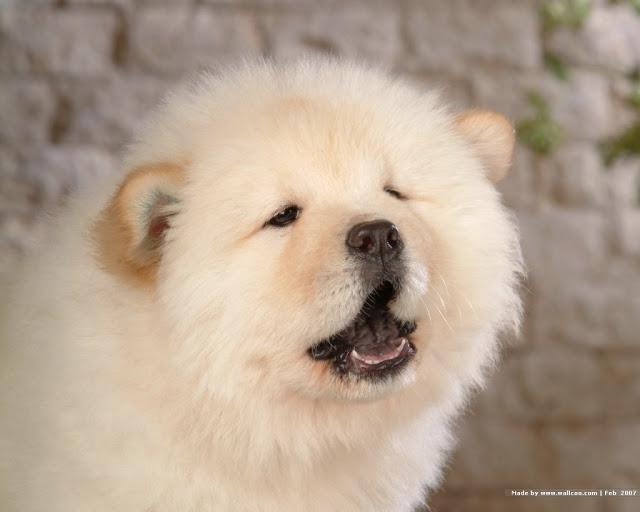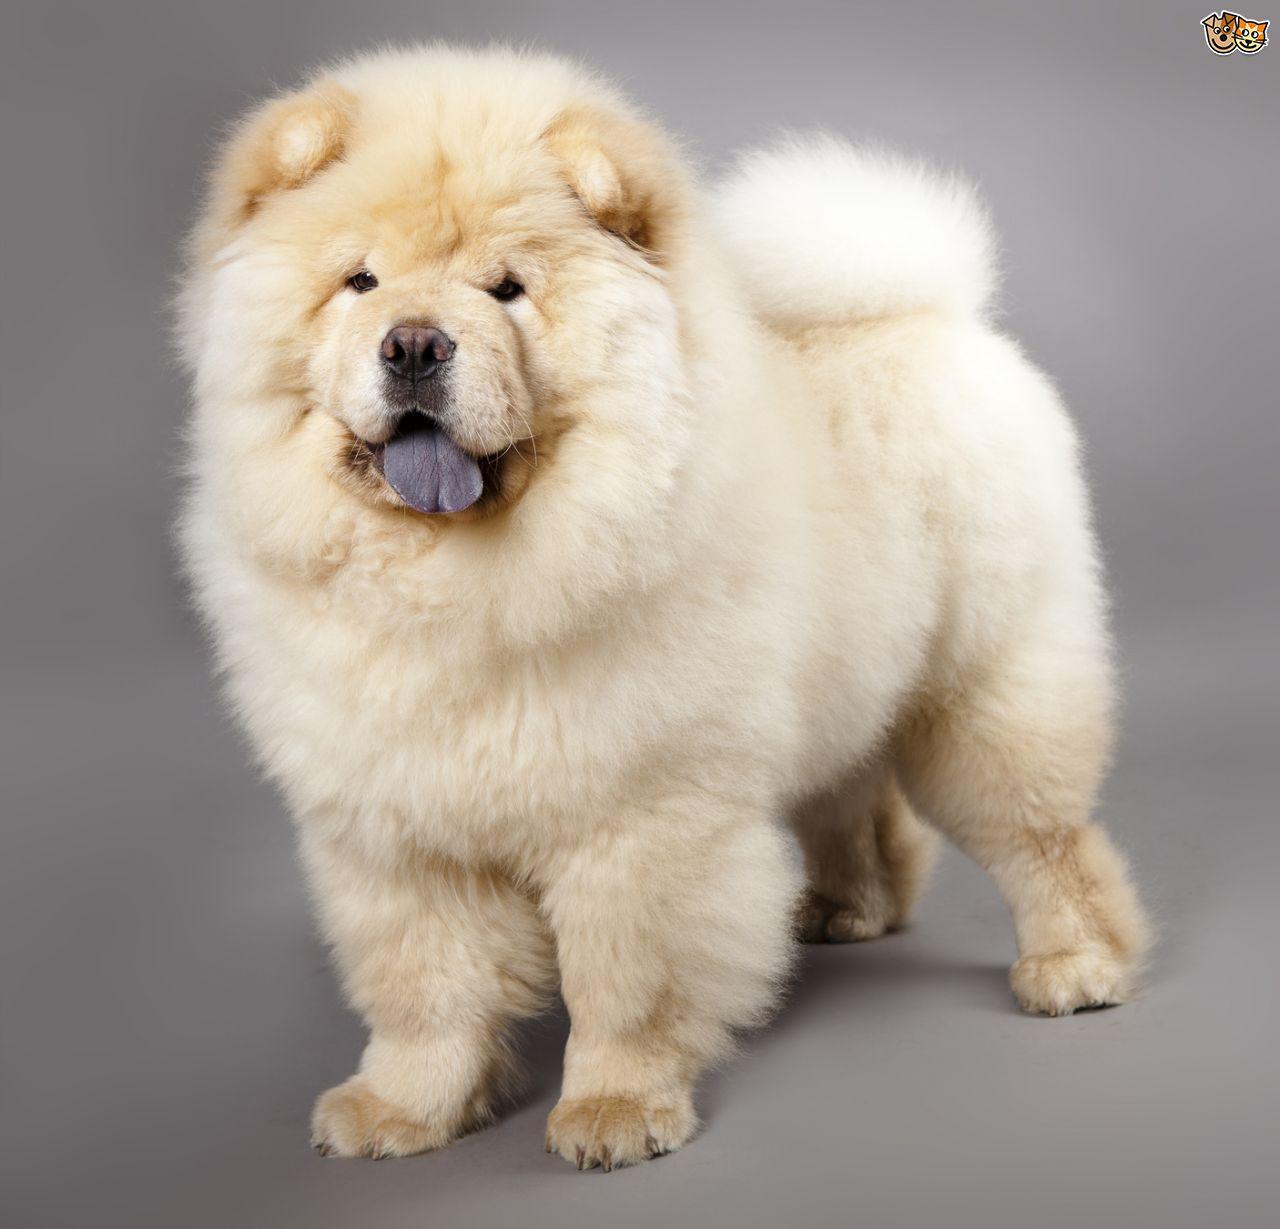The first image is the image on the left, the second image is the image on the right. For the images displayed, is the sentence "The dog in the image on the right has its mouth open" factually correct? Answer yes or no. Yes. 